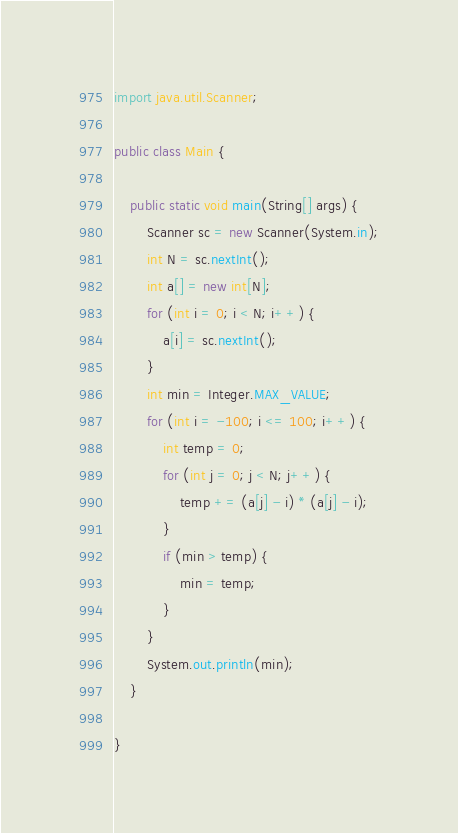<code> <loc_0><loc_0><loc_500><loc_500><_Java_>import java.util.Scanner;

public class Main {

	public static void main(String[] args) {
		Scanner sc = new Scanner(System.in);
		int N = sc.nextInt();
		int a[] = new int[N];
		for (int i = 0; i < N; i++) {
			a[i] = sc.nextInt();
		}
		int min = Integer.MAX_VALUE;
		for (int i = -100; i <= 100; i++) {
			int temp = 0;
			for (int j = 0; j < N; j++) {
				temp += (a[j] - i) * (a[j] - i);
			}
			if (min > temp) {
				min = temp;
			}
		}
		System.out.println(min);
	}

}</code> 